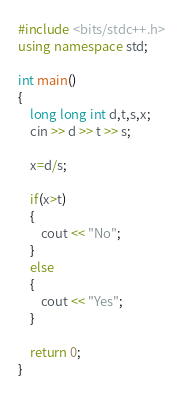<code> <loc_0><loc_0><loc_500><loc_500><_C++_>#include <bits/stdc++.h>
using namespace std;

int main()
{
    long long int d,t,s,x;
    cin >> d >> t >> s;
    
    x=d/s;
    
    if(x>t)
    {
        cout << "No";
    }
    else 
    {
        cout << "Yes";
    }

    return 0;
}</code> 